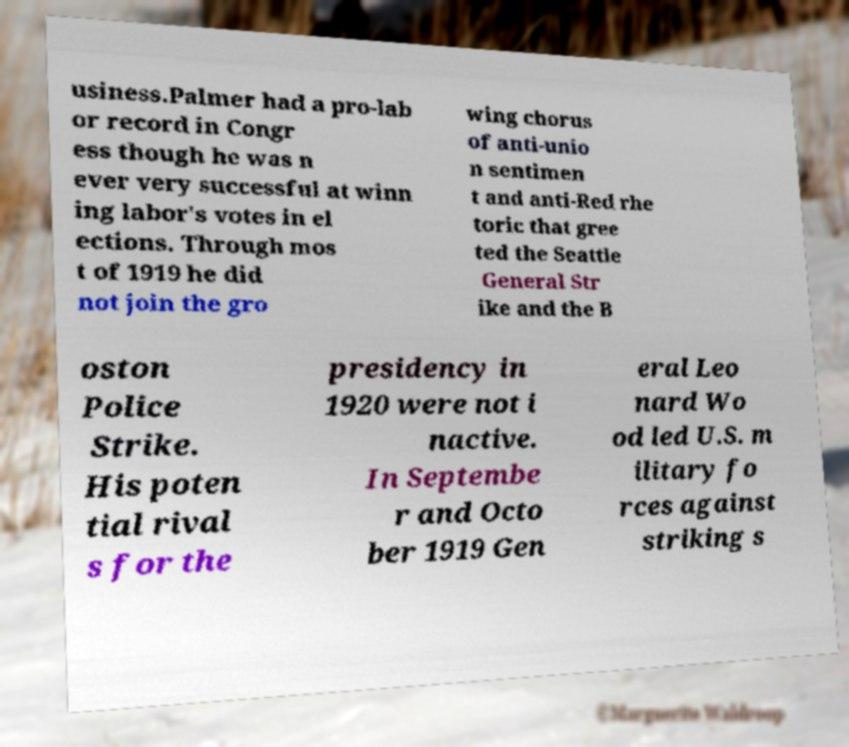Can you read and provide the text displayed in the image?This photo seems to have some interesting text. Can you extract and type it out for me? usiness.Palmer had a pro-lab or record in Congr ess though he was n ever very successful at winn ing labor's votes in el ections. Through mos t of 1919 he did not join the gro wing chorus of anti-unio n sentimen t and anti-Red rhe toric that gree ted the Seattle General Str ike and the B oston Police Strike. His poten tial rival s for the presidency in 1920 were not i nactive. In Septembe r and Octo ber 1919 Gen eral Leo nard Wo od led U.S. m ilitary fo rces against striking s 